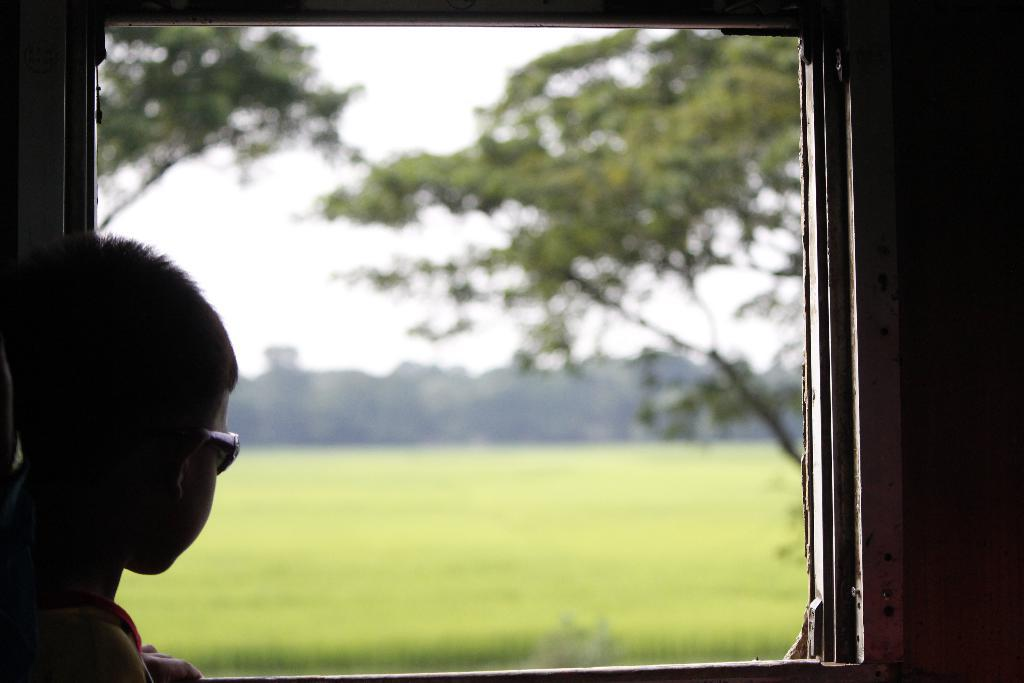What is present in the image? There is a person in the image. Can you describe the person's appearance? The person is wearing glasses. What can be seen in the background of the image? Trees and grass are visible in the background. How would you describe the sky in the image? The sky appears to be white in color. What rod is the person using to make a decision in the image? There is no rod present in the image, nor is there any indication that the person is making a decision. 